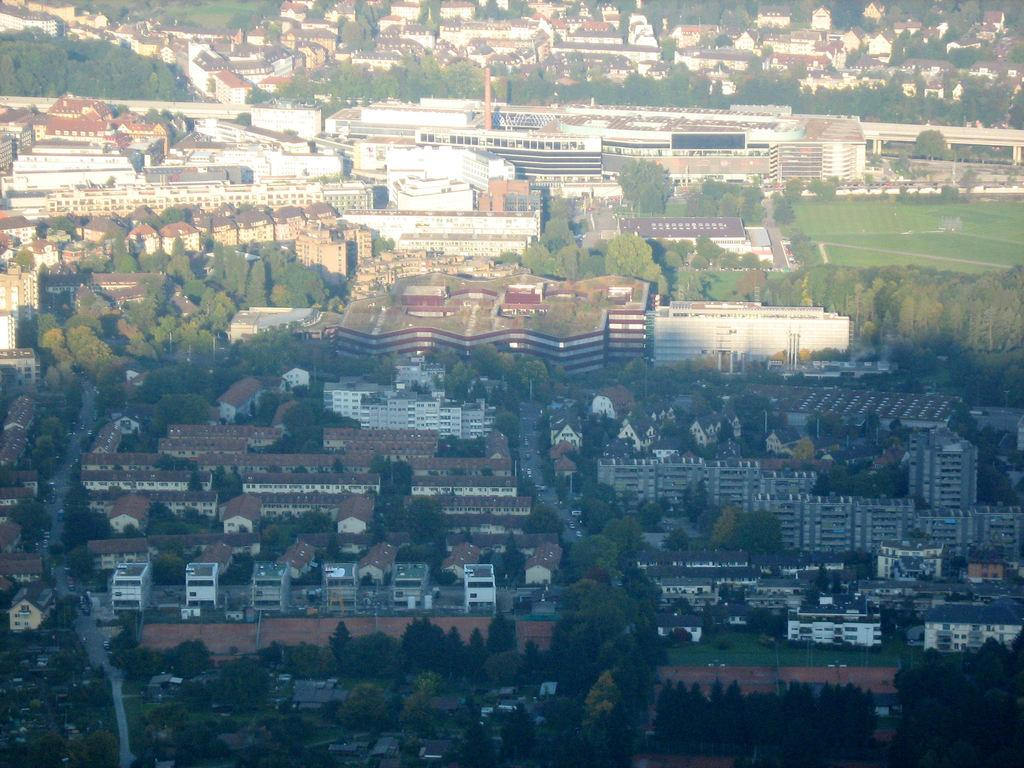What can be seen in the foreground of the image? There are many trees and buildings in the foreground of the image. What type of vegetation is present on the right side of the image? There is grass on the right side of the image. What is visible on the left side of the image? There is a road visible on the left side of the image. What type of oatmeal is being served on the road in the image? There is no oatmeal or meal present in the image; it features trees, buildings, grass, and a road. What kind of truck can be seen driving on the grass in the image? There is no truck visible in the image; it only shows trees, buildings, grass, and a road. 